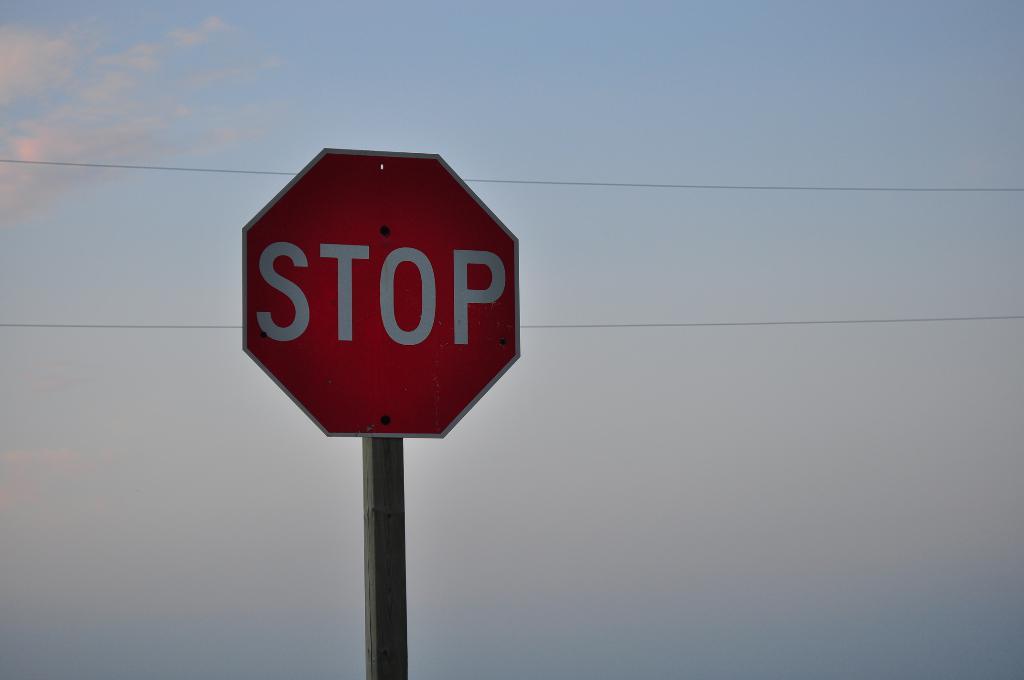What is this sign telling us to do?
Your answer should be compact. Stop. What shape is this sign?
Your answer should be very brief. Answering does not require reading text in the image. 